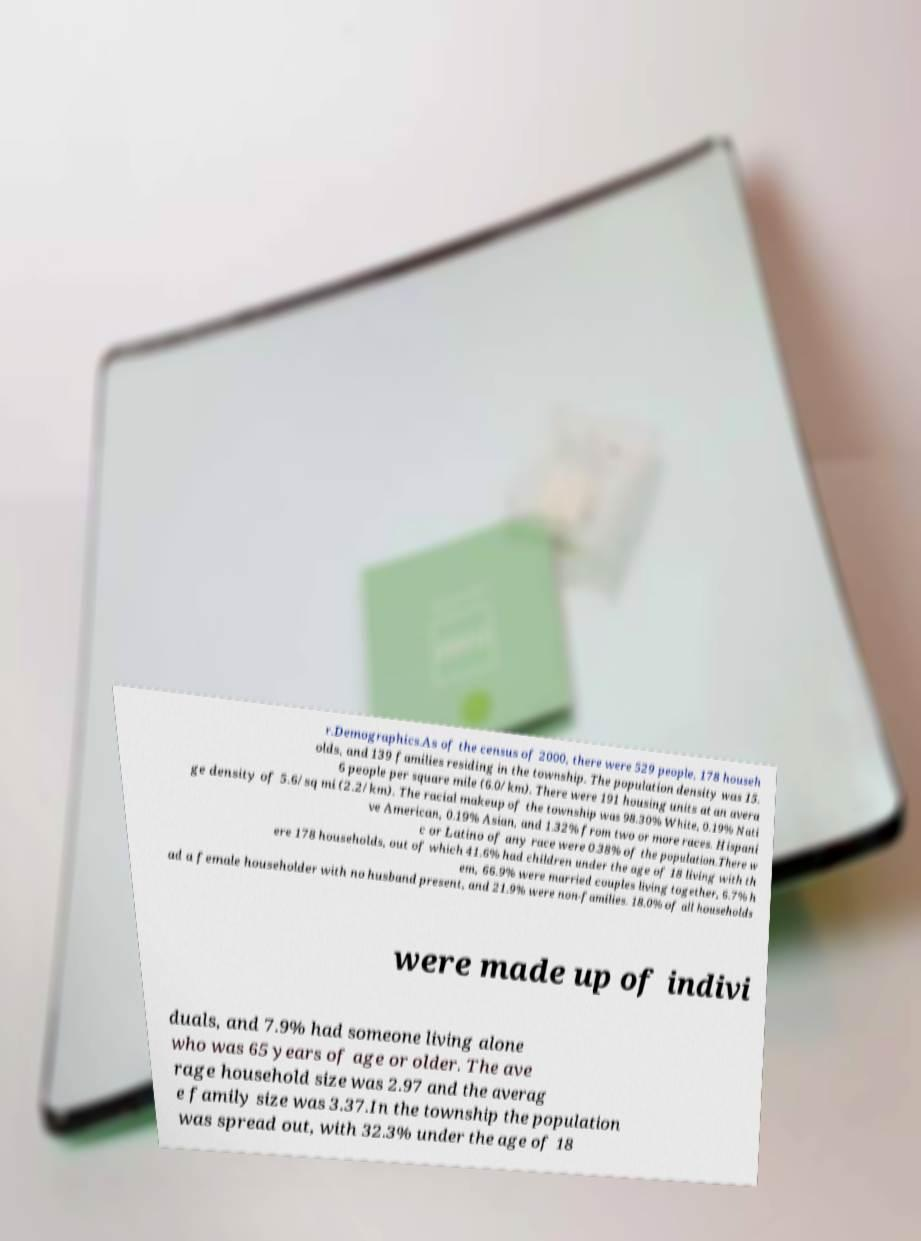Can you accurately transcribe the text from the provided image for me? r.Demographics.As of the census of 2000, there were 529 people, 178 househ olds, and 139 families residing in the township. The population density was 15. 6 people per square mile (6.0/km). There were 191 housing units at an avera ge density of 5.6/sq mi (2.2/km). The racial makeup of the township was 98.30% White, 0.19% Nati ve American, 0.19% Asian, and 1.32% from two or more races. Hispani c or Latino of any race were 0.38% of the population.There w ere 178 households, out of which 41.6% had children under the age of 18 living with th em, 66.9% were married couples living together, 6.7% h ad a female householder with no husband present, and 21.9% were non-families. 18.0% of all households were made up of indivi duals, and 7.9% had someone living alone who was 65 years of age or older. The ave rage household size was 2.97 and the averag e family size was 3.37.In the township the population was spread out, with 32.3% under the age of 18 